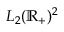<formula> <loc_0><loc_0><loc_500><loc_500>L _ { 2 } ( \mathbb { R } _ { + } ) ^ { 2 }</formula> 